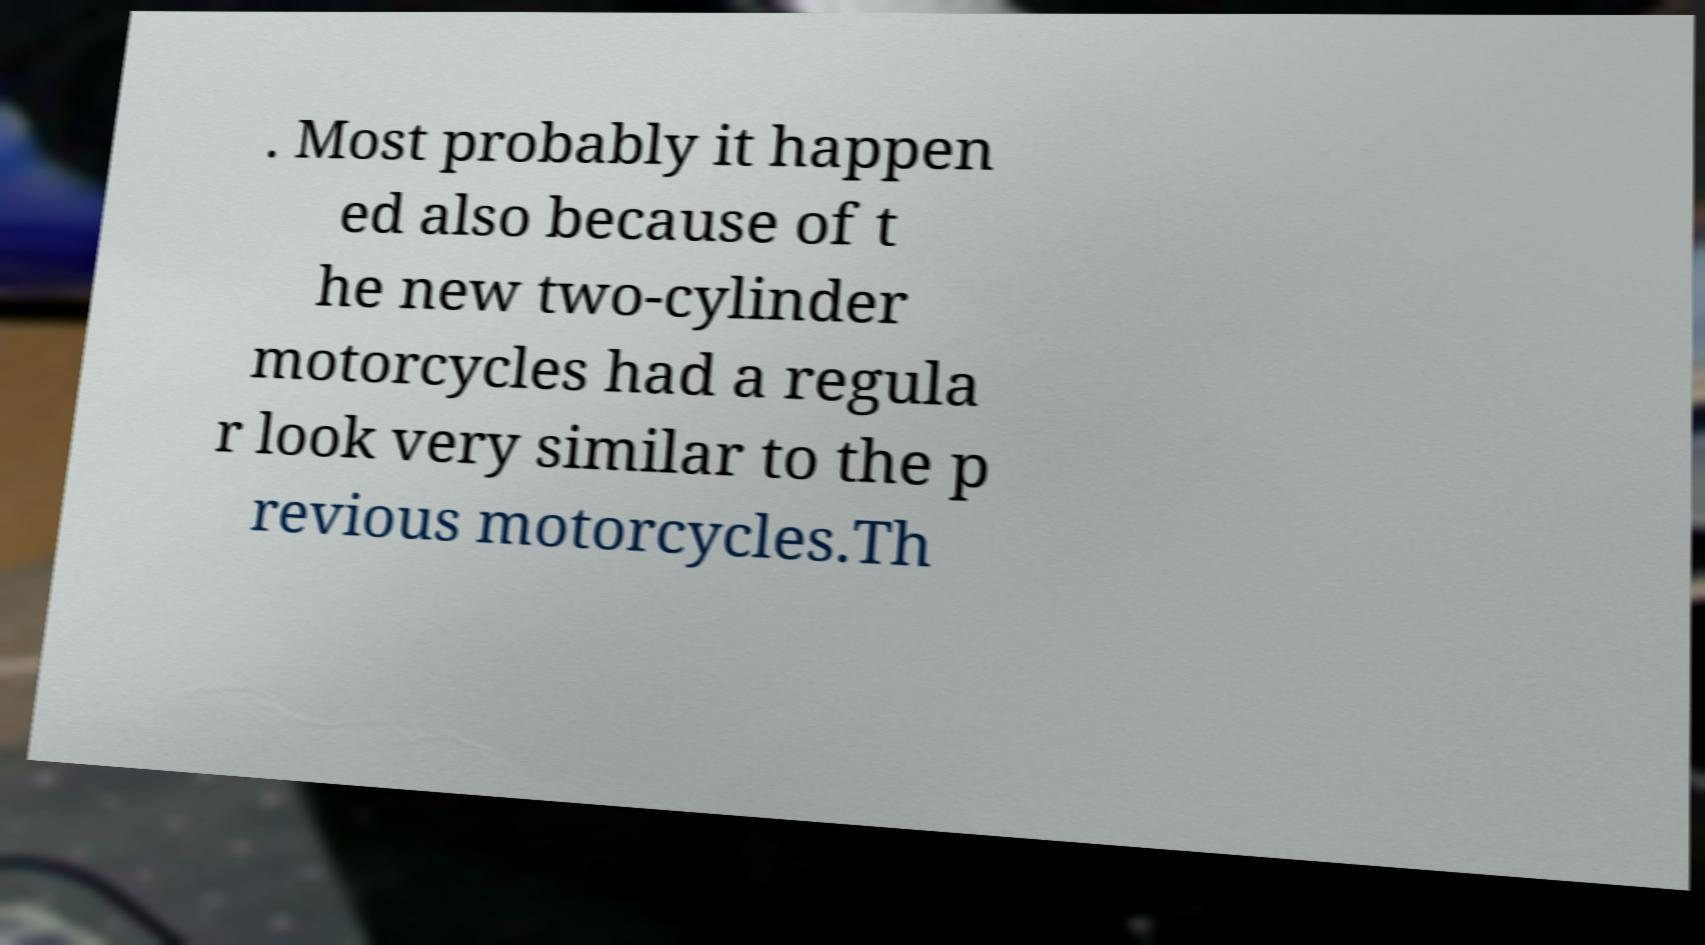Could you extract and type out the text from this image? . Most probably it happen ed also because of t he new two-cylinder motorcycles had a regula r look very similar to the p revious motorcycles.Th 